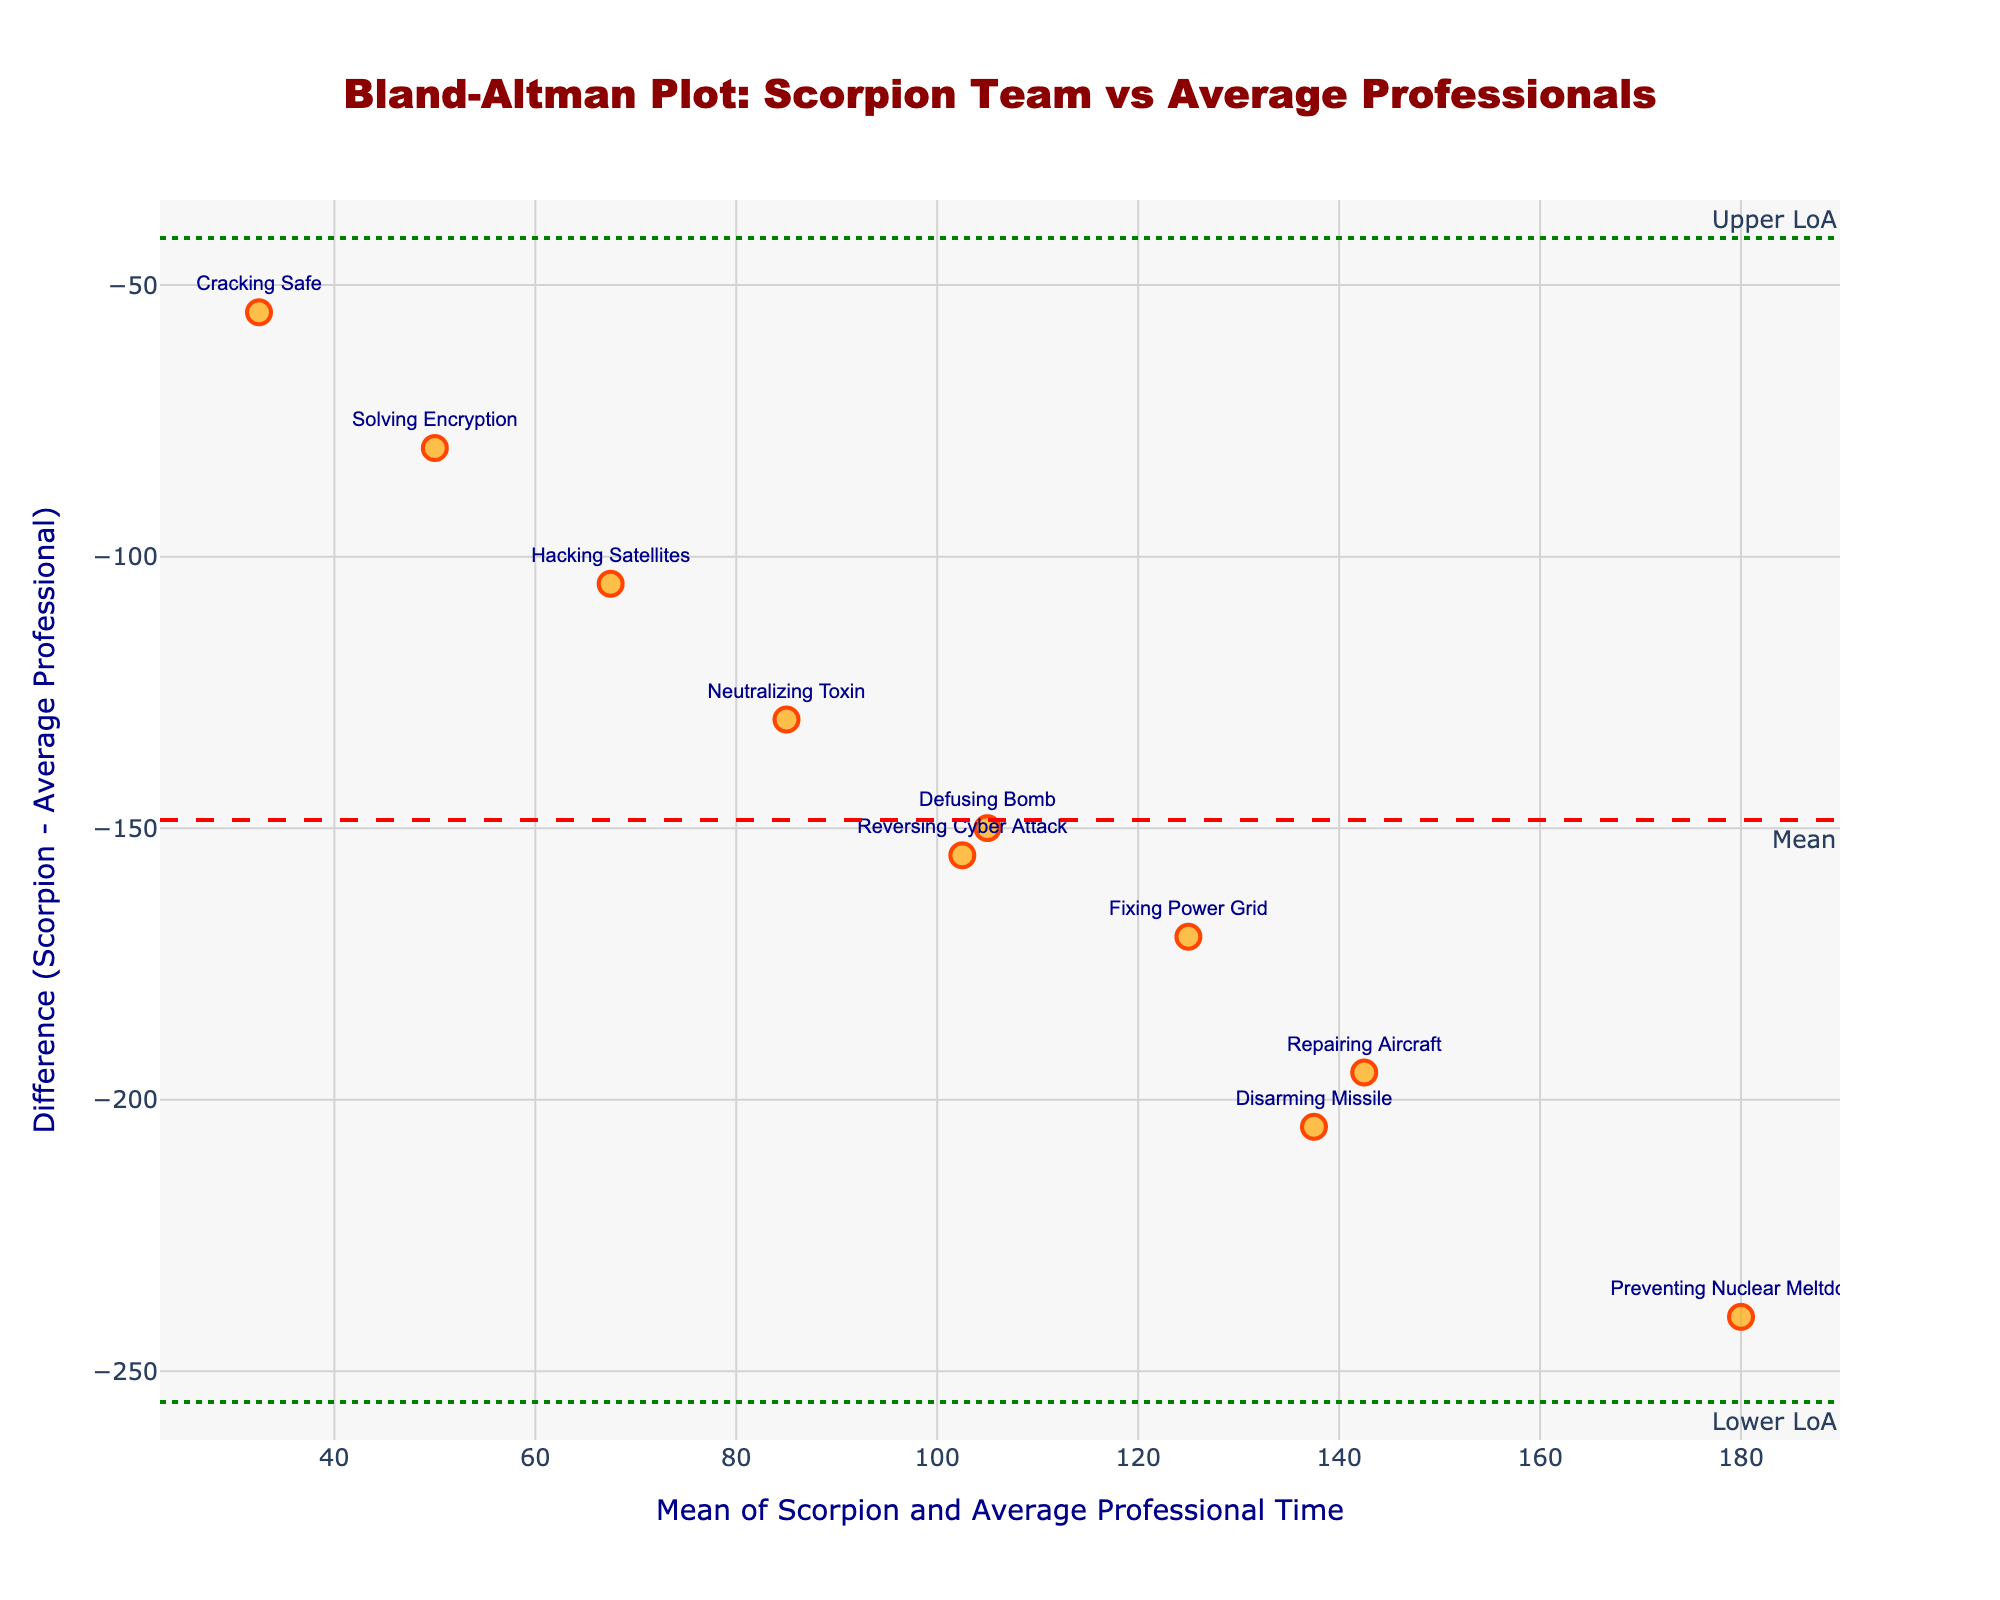What's the title of the figure? The title of the figure is prominently displayed at the top. It reads "Bland-Altman Plot: Scorpion Team vs Average Professionals".
Answer: Bland-Altman Plot: Scorpion Team vs Average Professionals How many data points are plotted in the figure? You can count the number of markers (each representing a data point). There are 10 markers on the plot, one for each problem listed in the data.
Answer: 10 What's the average difference between Scorpion team times and average professional times? The plot shows a dashed red line representing the mean difference. This line indicates the average difference is at the y-axis value where it intersects.
Answer: -166 Which problem has the maximum difference (absolute value) between Scorpion team time and average professional time? By looking for the data point farthest from the zero line on the y-axis (in terms of absolute value), you would find the "Preventing Nuclear Meltdown" data point. The y-value (difference) is -240.
Answer: Preventing Nuclear Meltdown What is the mean of Scorpion team time and average professional time for "Defusing Bomb"? Locate the point labeled "Defusing Bomb" on the plot. The x-axis value of this point (mean) can be seen as the point's position on the horizontal scale. Mean = (30 + 180) / 2 = 105.
Answer: 105 Are there any problems where the Scorpion team's time is quicker than the upper limit of agreement? The upper limit of agreement (Upper LoA) is marked by a dotted green line, above which there is no data point. This means the Scorpion team solved all problems quicker than the upper limit.
Answer: No What is the upper limit of agreement (Upper LoA)? The upper limit of agreement is shown on the figure by the upper green dotted line. The y-value where this line is placed is the Upper LoA.
Answer: -89 How many problems have a difference (Scorpion time - Average professional time) close to the mean difference? Look for data points close to the horizontal dashed red line (mean difference). Two points: "Repairing Aircraft" and "Disarming Missile" are the closest.
Answer: 2 Which problem took the Scorpion team the least time to solve? By examining the vertical distance from the data points to the x-axis, the point labeled "Cracking Safe" is the nearest, indicating the shortest Scorpion team time (5 minutes).
Answer: Cracking Safe What does the green dotted line represent? The green dotted lines represent the limits of agreement (LoA), which are calculated as mean difference ± 1.96 times the standard deviation of the differences.
Answer: Limits of agreement 